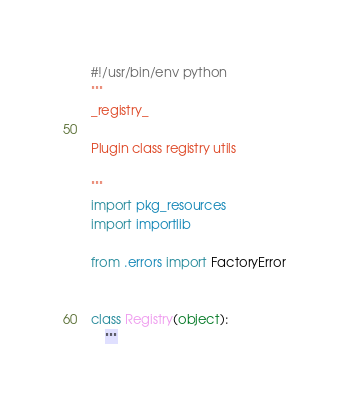Convert code to text. <code><loc_0><loc_0><loc_500><loc_500><_Python_>#!/usr/bin/env python
"""
_registry_

Plugin class registry utils

"""
import pkg_resources
import importlib

from .errors import FactoryError


class Registry(object):
    """</code> 